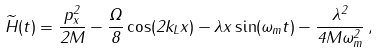<formula> <loc_0><loc_0><loc_500><loc_500>\widetilde { H } ( t ) = \frac { p _ { x } ^ { 2 } } { 2 M } - \frac { \Omega } { 8 } \cos ( 2 k _ { L } x ) - \lambda x \sin ( \omega _ { m } t ) - \frac { \lambda ^ { 2 } } { 4 M \omega _ { m } ^ { 2 } } \, ,</formula> 